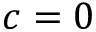Convert formula to latex. <formula><loc_0><loc_0><loc_500><loc_500>c = 0</formula> 